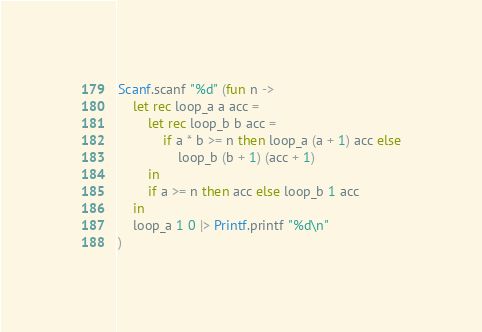<code> <loc_0><loc_0><loc_500><loc_500><_OCaml_>Scanf.scanf "%d" (fun n ->
    let rec loop_a a acc =
        let rec loop_b b acc =
            if a * b >= n then loop_a (a + 1) acc else
                loop_b (b + 1) (acc + 1)
        in
        if a >= n then acc else loop_b 1 acc
    in
    loop_a 1 0 |> Printf.printf "%d\n"
)</code> 